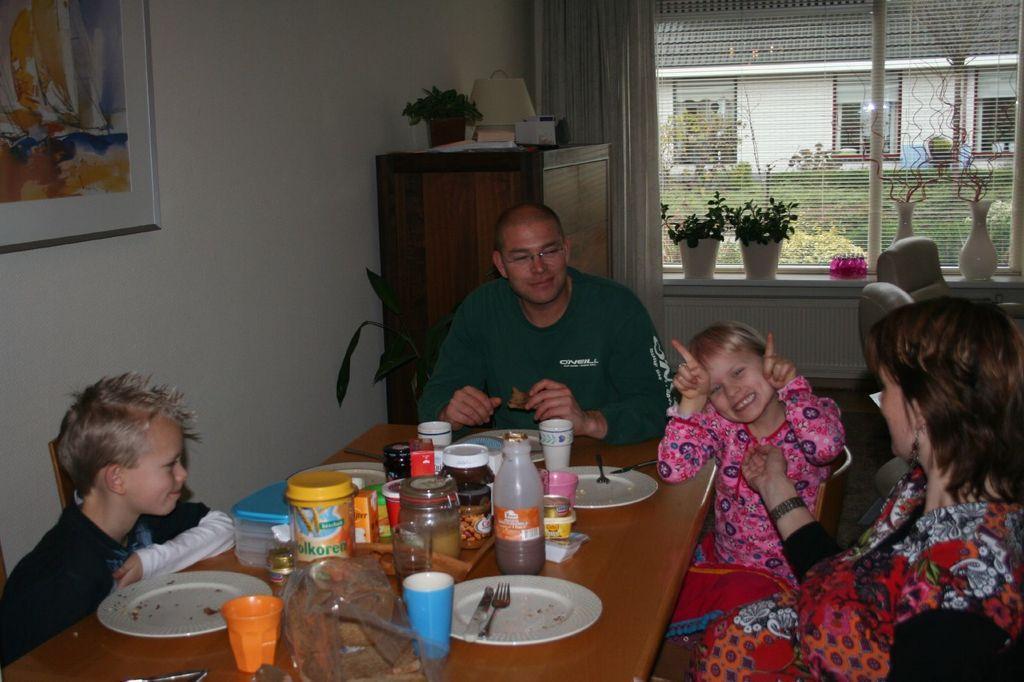Please provide a concise description of this image. The image is taken inside a room. In the center of the room there is a table. There are people sitting around a table. There are chairs. There is a wardrobe. In the background there is a window, a curtain and plants which are placed on the wall. On the table there are glasses, bottles, plates, spoons, forks and some boxes. 